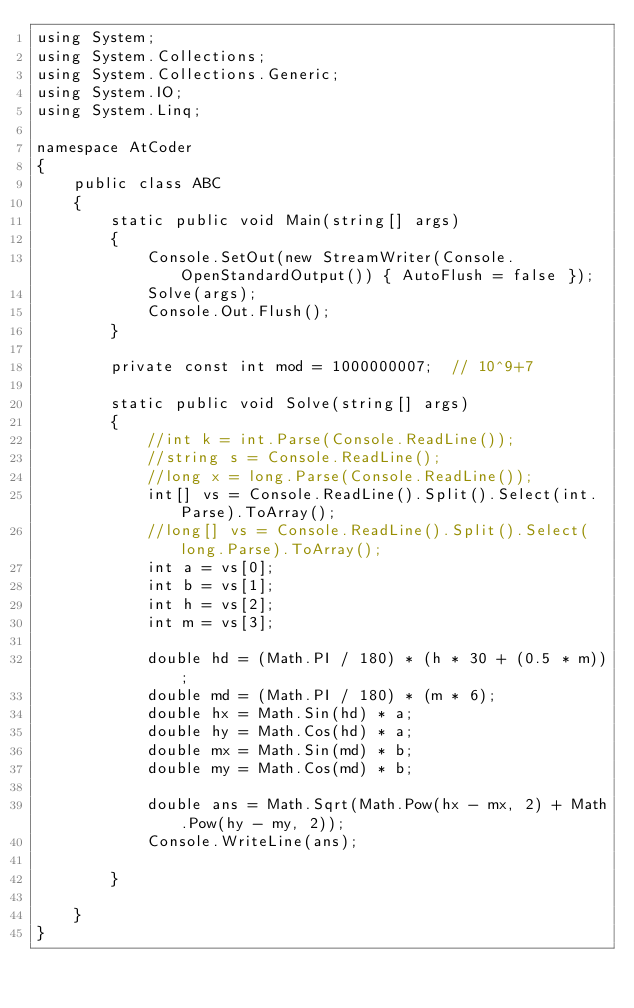<code> <loc_0><loc_0><loc_500><loc_500><_C#_>using System;
using System.Collections;
using System.Collections.Generic;
using System.IO;
using System.Linq;

namespace AtCoder
{
	public class ABC
	{
		static public void Main(string[] args)
		{
			Console.SetOut(new StreamWriter(Console.OpenStandardOutput()) { AutoFlush = false });
			Solve(args);
			Console.Out.Flush();
		}

		private const int mod = 1000000007;  // 10^9+7

		static public void Solve(string[] args)
		{
			//int k = int.Parse(Console.ReadLine());
			//string s = Console.ReadLine();
			//long x = long.Parse(Console.ReadLine());
			int[] vs = Console.ReadLine().Split().Select(int.Parse).ToArray();
			//long[] vs = Console.ReadLine().Split().Select(long.Parse).ToArray();
			int a = vs[0];
			int b = vs[1];
			int h = vs[2];
			int m = vs[3];

			double hd = (Math.PI / 180) * (h * 30 + (0.5 * m));
			double md = (Math.PI / 180) * (m * 6);
			double hx = Math.Sin(hd) * a;
			double hy = Math.Cos(hd) * a;
			double mx = Math.Sin(md) * b;
			double my = Math.Cos(md) * b;

			double ans = Math.Sqrt(Math.Pow(hx - mx, 2) + Math.Pow(hy - my, 2));
			Console.WriteLine(ans);

		}

	}
}
</code> 